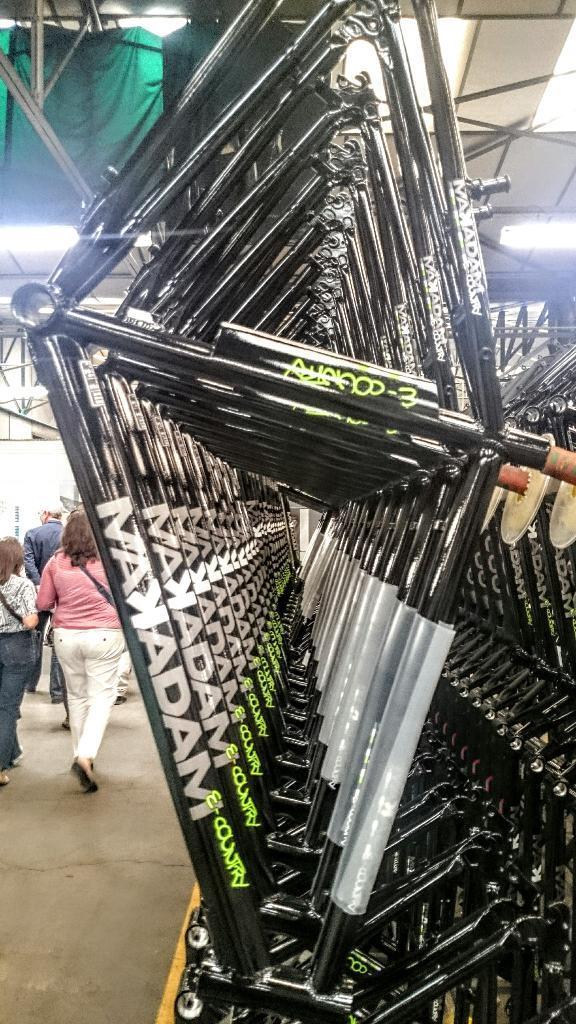Describe this image in one or two sentences. In this image, I can see the frames of the bicycles. On the left side of the image, there are few people walking on a pathway. At the top of the image, I can see a cloth and there are ceiling lights. 